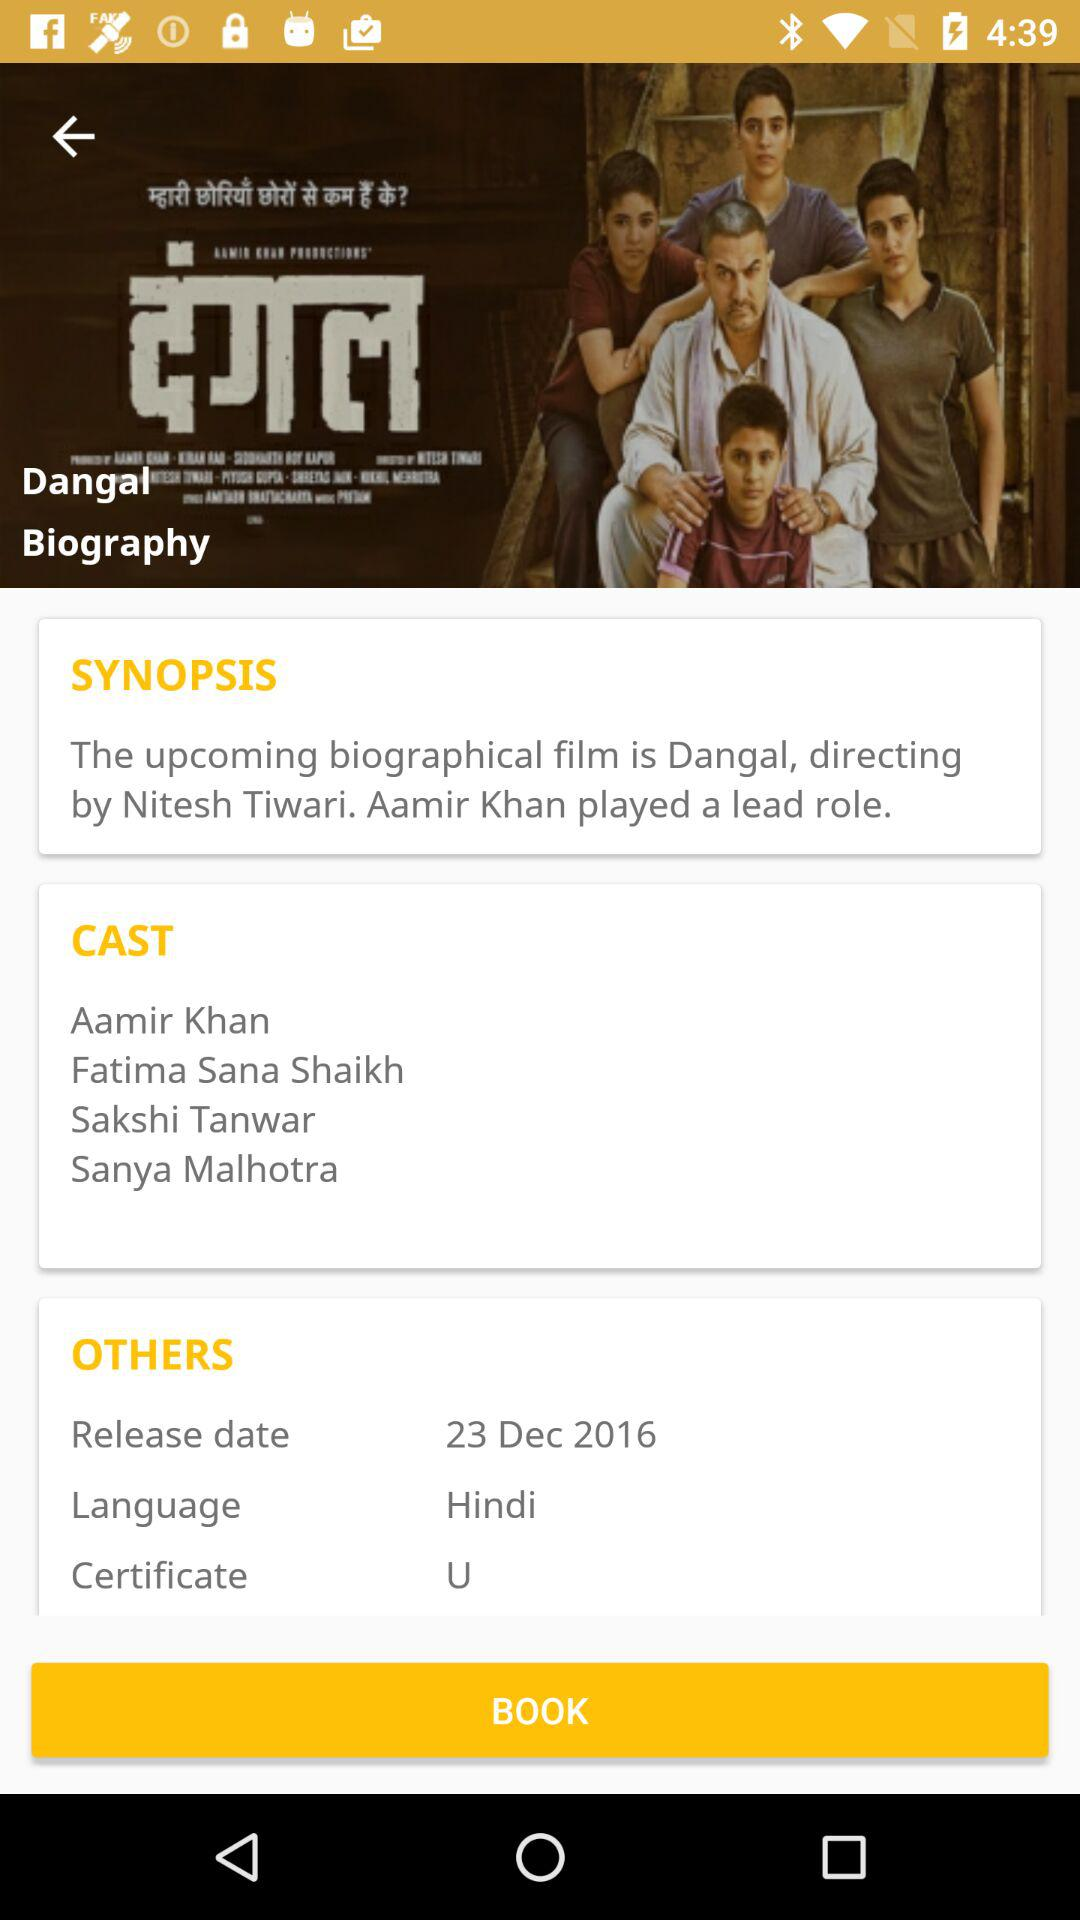What is the release date? The release date is December 23, 2016. 